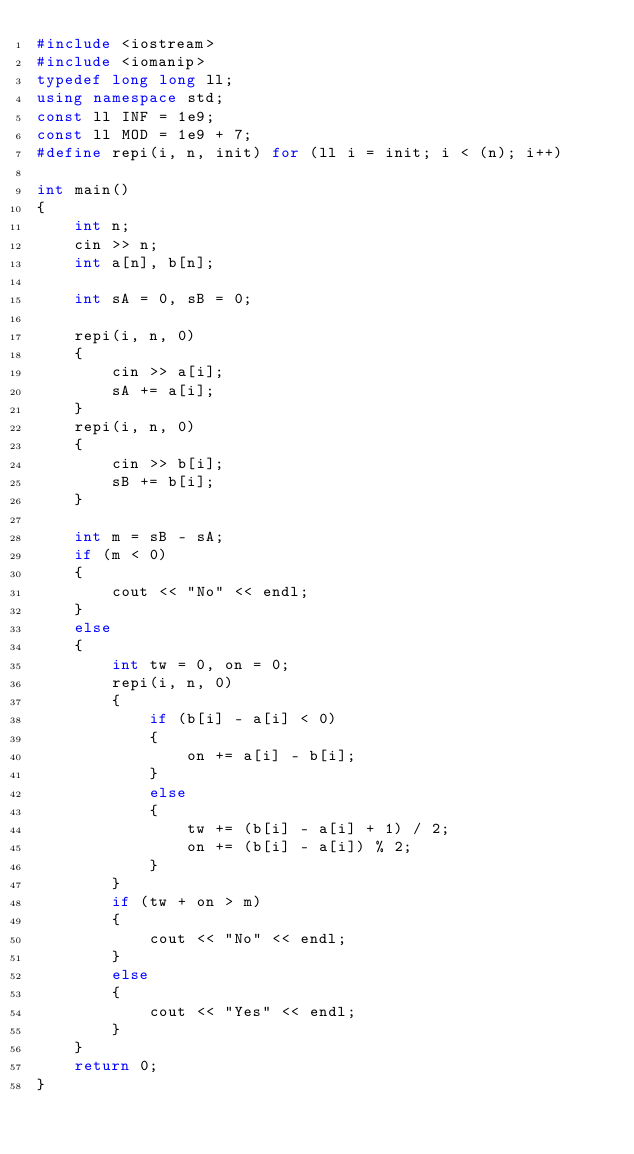Convert code to text. <code><loc_0><loc_0><loc_500><loc_500><_C++_>#include <iostream>
#include <iomanip>
typedef long long ll;
using namespace std;
const ll INF = 1e9;
const ll MOD = 1e9 + 7;
#define repi(i, n, init) for (ll i = init; i < (n); i++)

int main()
{
    int n;
    cin >> n;
    int a[n], b[n];

    int sA = 0, sB = 0;

    repi(i, n, 0)
    {
        cin >> a[i];
        sA += a[i];
    }
    repi(i, n, 0)
    {
        cin >> b[i];
        sB += b[i];
    }

    int m = sB - sA;
    if (m < 0)
    {
        cout << "No" << endl;
    }
    else
    {
        int tw = 0, on = 0;
        repi(i, n, 0)
        {
            if (b[i] - a[i] < 0)
            {
                on += a[i] - b[i];
            }
            else
            {
                tw += (b[i] - a[i] + 1) / 2;
                on += (b[i] - a[i]) % 2;
            }
        }
        if (tw + on > m)
        {
            cout << "No" << endl;
        }
        else
        {
            cout << "Yes" << endl;
        }
    }
    return 0;
}</code> 